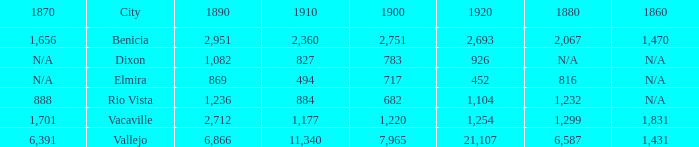What is the 1920 number when 1890 is greater than 1,236, 1910 is less than 1,177 and the city is Vacaville? None. 